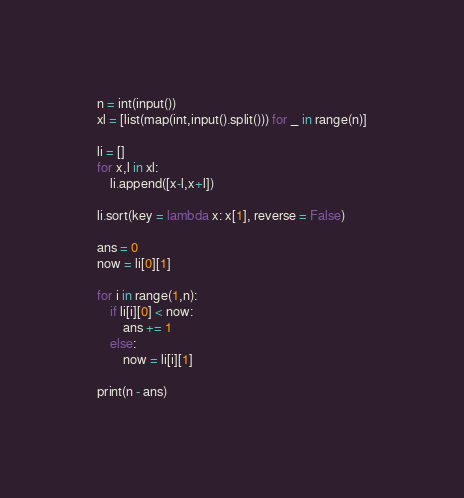<code> <loc_0><loc_0><loc_500><loc_500><_Python_>n = int(input())
xl = [list(map(int,input().split())) for _ in range(n)]

li = []
for x,l in xl:
    li.append([x-l,x+l])

li.sort(key = lambda x: x[1], reverse = False)

ans = 0
now = li[0][1]

for i in range(1,n):
    if li[i][0] < now:
        ans += 1
    else:
        now = li[i][1]

print(n - ans)
</code> 